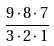Convert formula to latex. <formula><loc_0><loc_0><loc_500><loc_500>\frac { 9 \cdot 8 \cdot 7 } { 3 \cdot 2 \cdot 1 }</formula> 